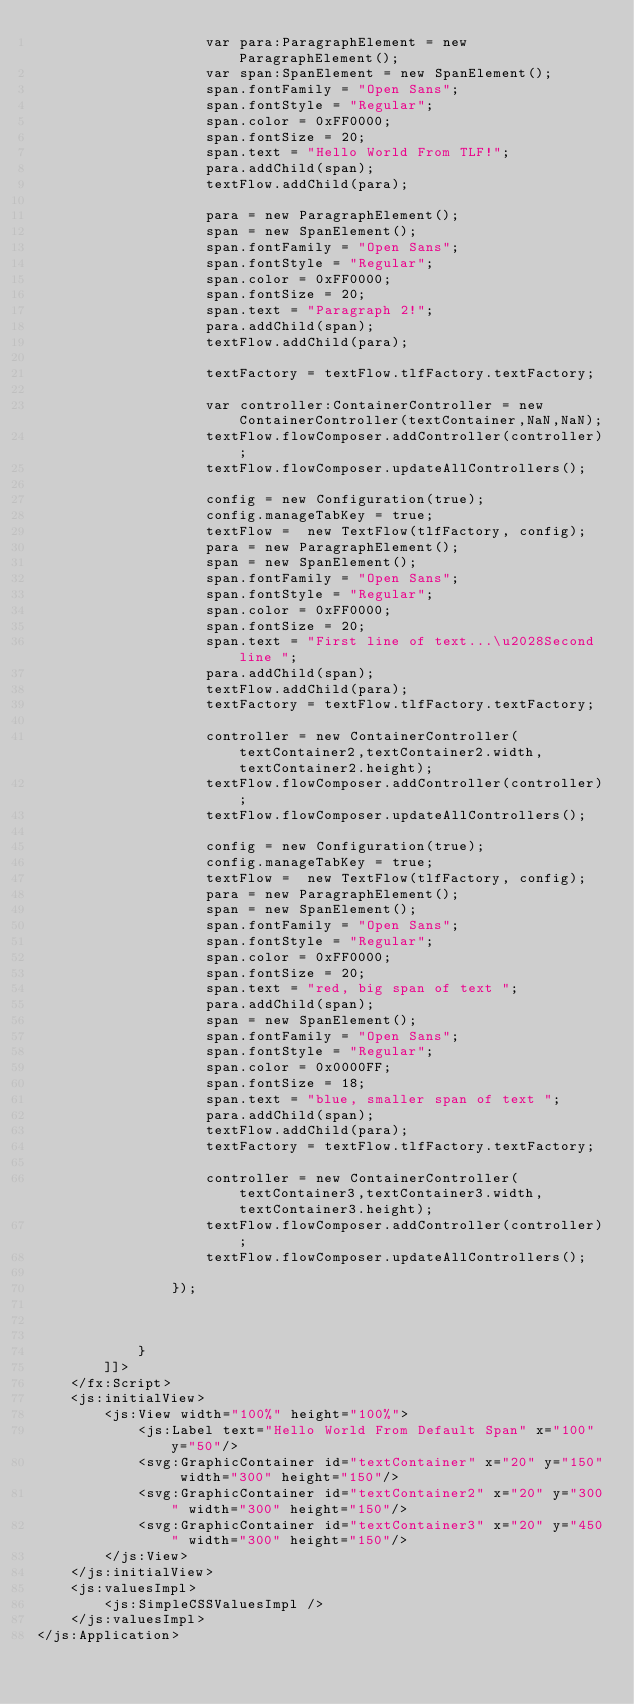Convert code to text. <code><loc_0><loc_0><loc_500><loc_500><_XML_>                    var para:ParagraphElement = new ParagraphElement();
                    var span:SpanElement = new SpanElement();
                    span.fontFamily = "Open Sans";
                    span.fontStyle = "Regular";
                    span.color = 0xFF0000;
                    span.fontSize = 20;
                    span.text = "Hello World From TLF!";
                    para.addChild(span);
                    textFlow.addChild(para);

                    para = new ParagraphElement();
                    span = new SpanElement();
                    span.fontFamily = "Open Sans";
                    span.fontStyle = "Regular";
                    span.color = 0xFF0000;
                    span.fontSize = 20;
                    span.text = "Paragraph 2!";
                    para.addChild(span);
                    textFlow.addChild(para);

                    textFactory = textFlow.tlfFactory.textFactory;

                    var controller:ContainerController = new ContainerController(textContainer,NaN,NaN);
                    textFlow.flowComposer.addController(controller);
                    textFlow.flowComposer.updateAllControllers();

                    config = new Configuration(true);		
                    config.manageTabKey = true;
                    textFlow =  new TextFlow(tlfFactory, config);
                    para = new ParagraphElement();
                    span = new SpanElement();
                    span.fontFamily = "Open Sans";
                    span.fontStyle = "Regular";
                    span.color = 0xFF0000;
                    span.fontSize = 20;
                    span.text = "First line of text...\u2028Second line ";
                    para.addChild(span);
                    textFlow.addChild(para);
                    textFactory = textFlow.tlfFactory.textFactory;

                    controller = new ContainerController(textContainer2,textContainer2.width,textContainer2.height);
                    textFlow.flowComposer.addController(controller);
                    textFlow.flowComposer.updateAllControllers();

                    config = new Configuration(true);		
                    config.manageTabKey = true;
                    textFlow =  new TextFlow(tlfFactory, config);
                    para = new ParagraphElement();
                    span = new SpanElement();
                    span.fontFamily = "Open Sans";
                    span.fontStyle = "Regular";
                    span.color = 0xFF0000;
                    span.fontSize = 20;
                    span.text = "red, big span of text ";
                    para.addChild(span);
                    span = new SpanElement();
                    span.fontFamily = "Open Sans";
                    span.fontStyle = "Regular";
                    span.color = 0x0000FF;
                    span.fontSize = 18;
                    span.text = "blue, smaller span of text ";
                    para.addChild(span);
                    textFlow.addChild(para);
                    textFactory = textFlow.tlfFactory.textFactory;

                    controller = new ContainerController(textContainer3,textContainer3.width,textContainer3.height);
                    textFlow.flowComposer.addController(controller);
                    textFlow.flowComposer.updateAllControllers();

                });


                
            }
        ]]>
    </fx:Script>
    <js:initialView> 
        <js:View width="100%" height="100%">
            <js:Label text="Hello World From Default Span" x="100" y="50"/>
            <svg:GraphicContainer id="textContainer" x="20" y="150" width="300" height="150"/>
            <svg:GraphicContainer id="textContainer2" x="20" y="300" width="300" height="150"/>
            <svg:GraphicContainer id="textContainer3" x="20" y="450" width="300" height="150"/>
        </js:View>
    </js:initialView>
    <js:valuesImpl>
        <js:SimpleCSSValuesImpl />
    </js:valuesImpl>
</js:Application></code> 